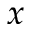Convert formula to latex. <formula><loc_0><loc_0><loc_500><loc_500>x</formula> 